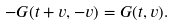<formula> <loc_0><loc_0><loc_500><loc_500>- G ( t + v , - v ) = G ( t , v ) .</formula> 